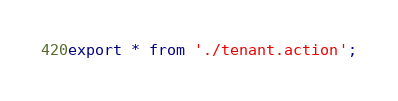<code> <loc_0><loc_0><loc_500><loc_500><_TypeScript_>export * from './tenant.action';
</code> 